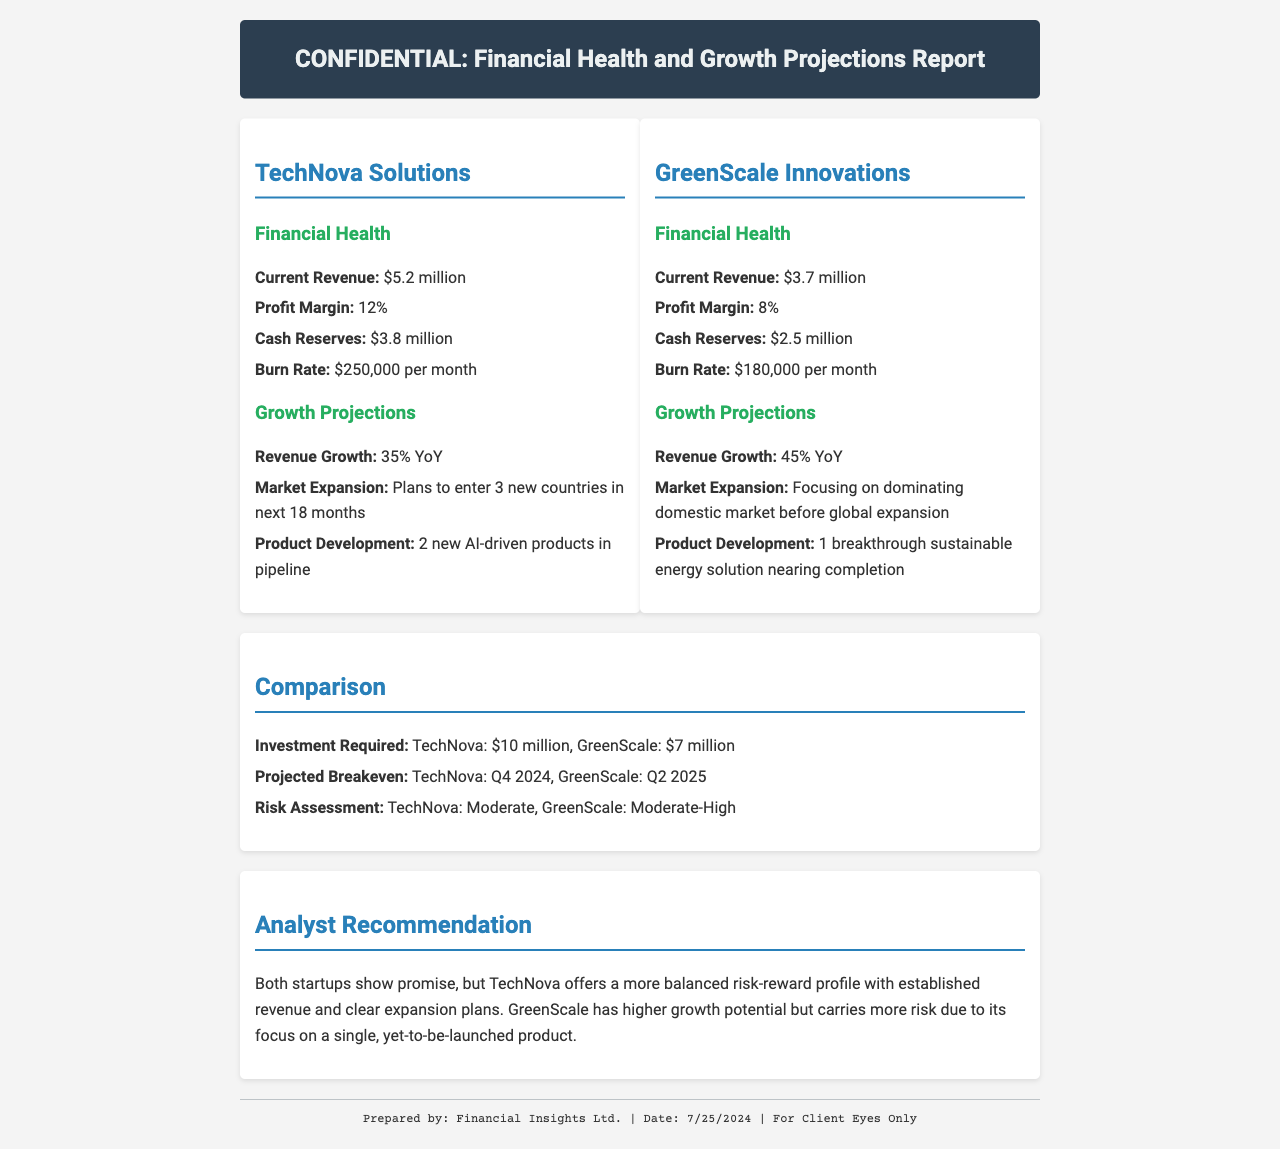What is the current revenue of TechNova Solutions? The current revenue is listed under the financial health section for TechNova Solutions.
Answer: $5.2 million What is the profit margin of GreenScale Innovations? The profit margin can be found in the financial health section for GreenScale Innovations.
Answer: 8% When does TechNova project to breakeven? The projected breakeven point is mentioned in the comparison section of the report.
Answer: Q4 2024 What is the cash reserve of GreenScale Innovations? The cash reserve figure is provided in the financial health section for GreenScale Innovations.
Answer: $2.5 million Which startup has a higher revenue growth projection? The revenue growth projections for both startups are compared, indicating which has the higher percentage.
Answer: GreenScale What is the investment required for TechNova Solutions? The required investment is specified in the comparison section of the report.
Answer: $10 million How many new countries does TechNova plan to enter in the next 18 months? The information is found in the growth projections section for TechNova Solutions.
Answer: 3 What kind of product development is GreenScale Innovations focused on? The type of product development is mentioned in the growth projections section for GreenScale Innovations.
Answer: A breakthrough sustainable energy solution What is the risk assessment for GreenScale Innovations? The risk assessment for both startups can be found in the comparison section of the report.
Answer: Moderate-High 